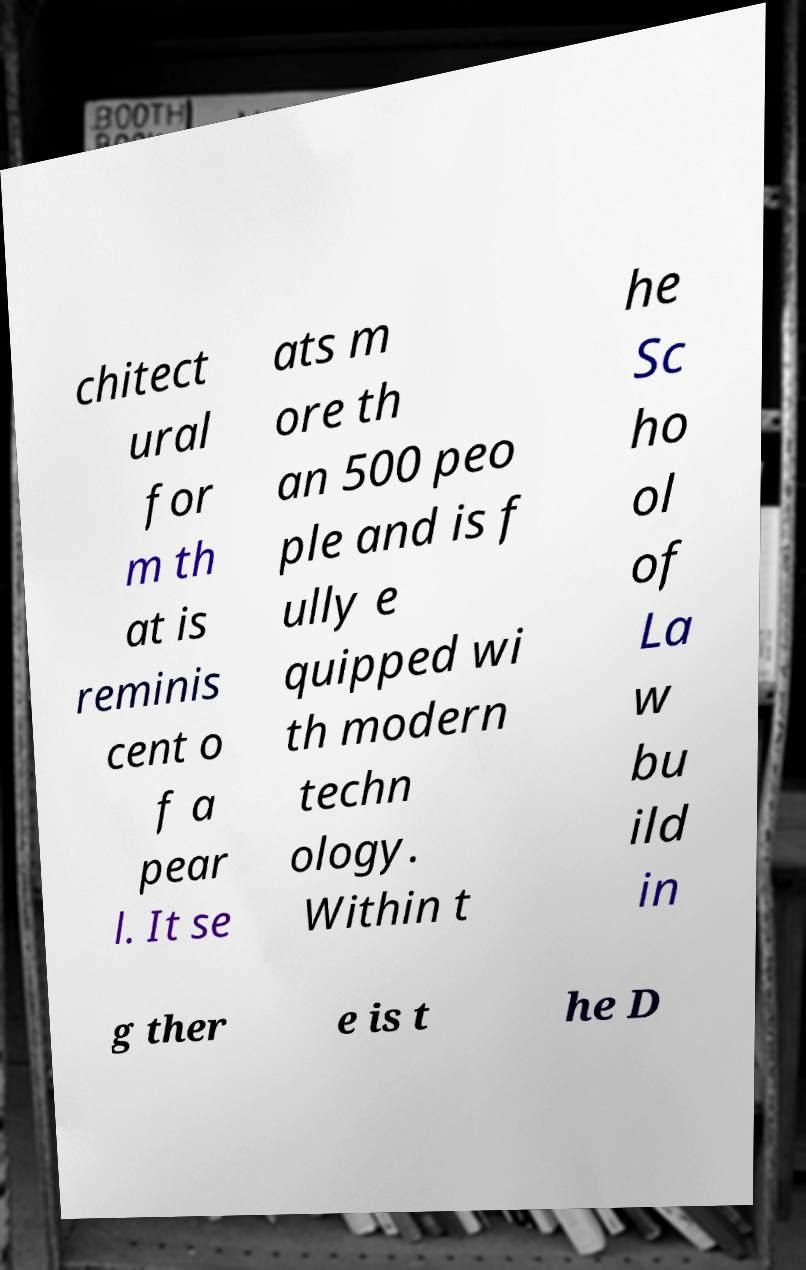For documentation purposes, I need the text within this image transcribed. Could you provide that? chitect ural for m th at is reminis cent o f a pear l. It se ats m ore th an 500 peo ple and is f ully e quipped wi th modern techn ology. Within t he Sc ho ol of La w bu ild in g ther e is t he D 